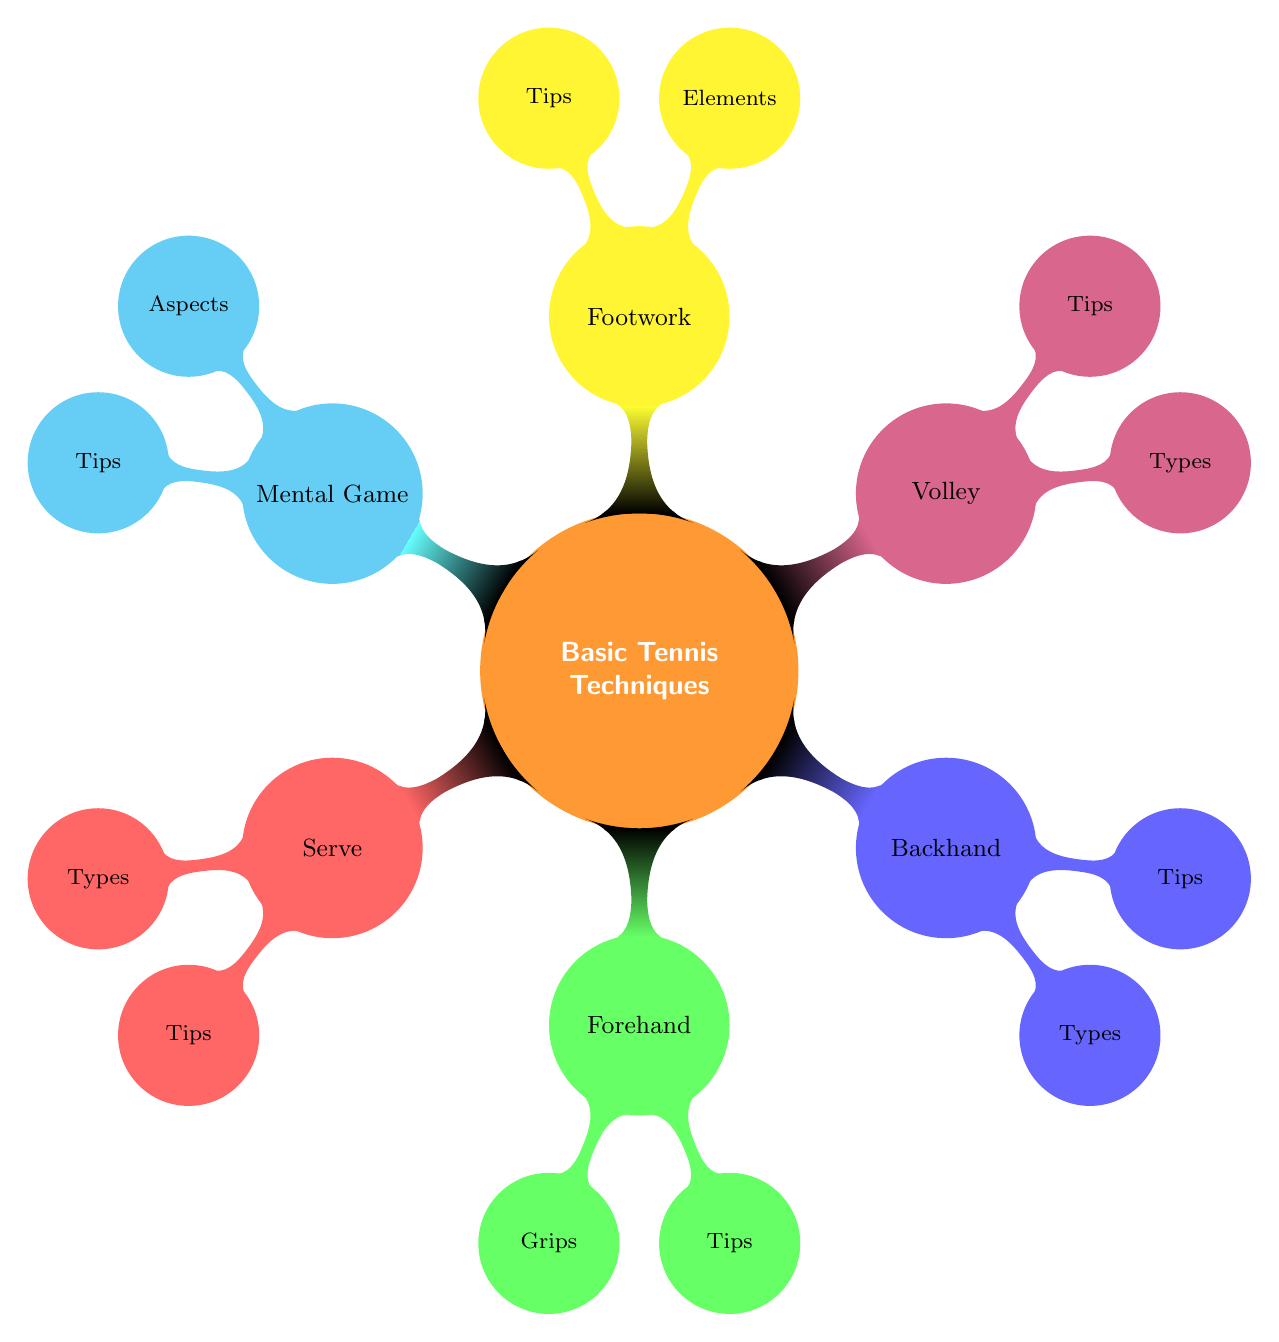What are the two main types of backhands? The diagram indicates that the Backhand section has two child nodes under "Types," specifically "One-Handed Backhand" and "Two-Handed Backhand." Therefore, I can conclude that the two main types of backhands are One-Handed Backhand and Two-Handed Backhand.
Answer: One-Handed Backhand, Two-Handed Backhand How many sections are in the Basic Tennis Techniques mind map? The main node titled "Basic Tennis Techniques" has six child nodes branching off it: Serve, Forehand, Backhand, Volley, Footwork, and Mental Game. Counting these child nodes gives a total of six sections.
Answer: 6 What is a recommended tip for improving the serve? The Tips section under Serve lists three specific tips, one of which is "Practice Toss Consistency." This directly answers the question regarding a recommended tip for improving the serve.
Answer: Practice Toss Consistency Which technique emphasizes the importance of footwork? In the mind map, the Footwork section has both "Elements" and "Tips." The existence of a dedicated section called "Footwork" implies it focuses on this technique, emphasizing its importance for tennis players.
Answer: Footwork What is one aspect of the mental game described in the map? The Mental Game section has "Aspects" as a child node, indicating various components. One stated aspect listed in the diagram is "Focus," which answers the question directly.
Answer: Focus What should you do to improve your volley? The Tips section under Volley provides key recommendations; one suggestion is "Stay Low and Balanced." This is a concise answer pointing to methods for improving the volley execution.
Answer: Stay Low and Balanced 